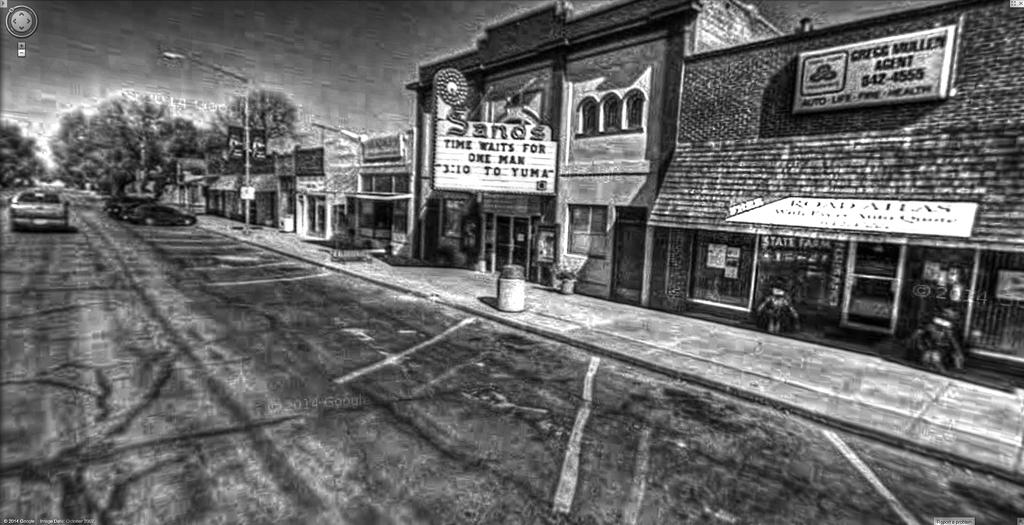<image>
Present a compact description of the photo's key features. Sands movie theatre is playing 3:10 to Yuma on the screen. 